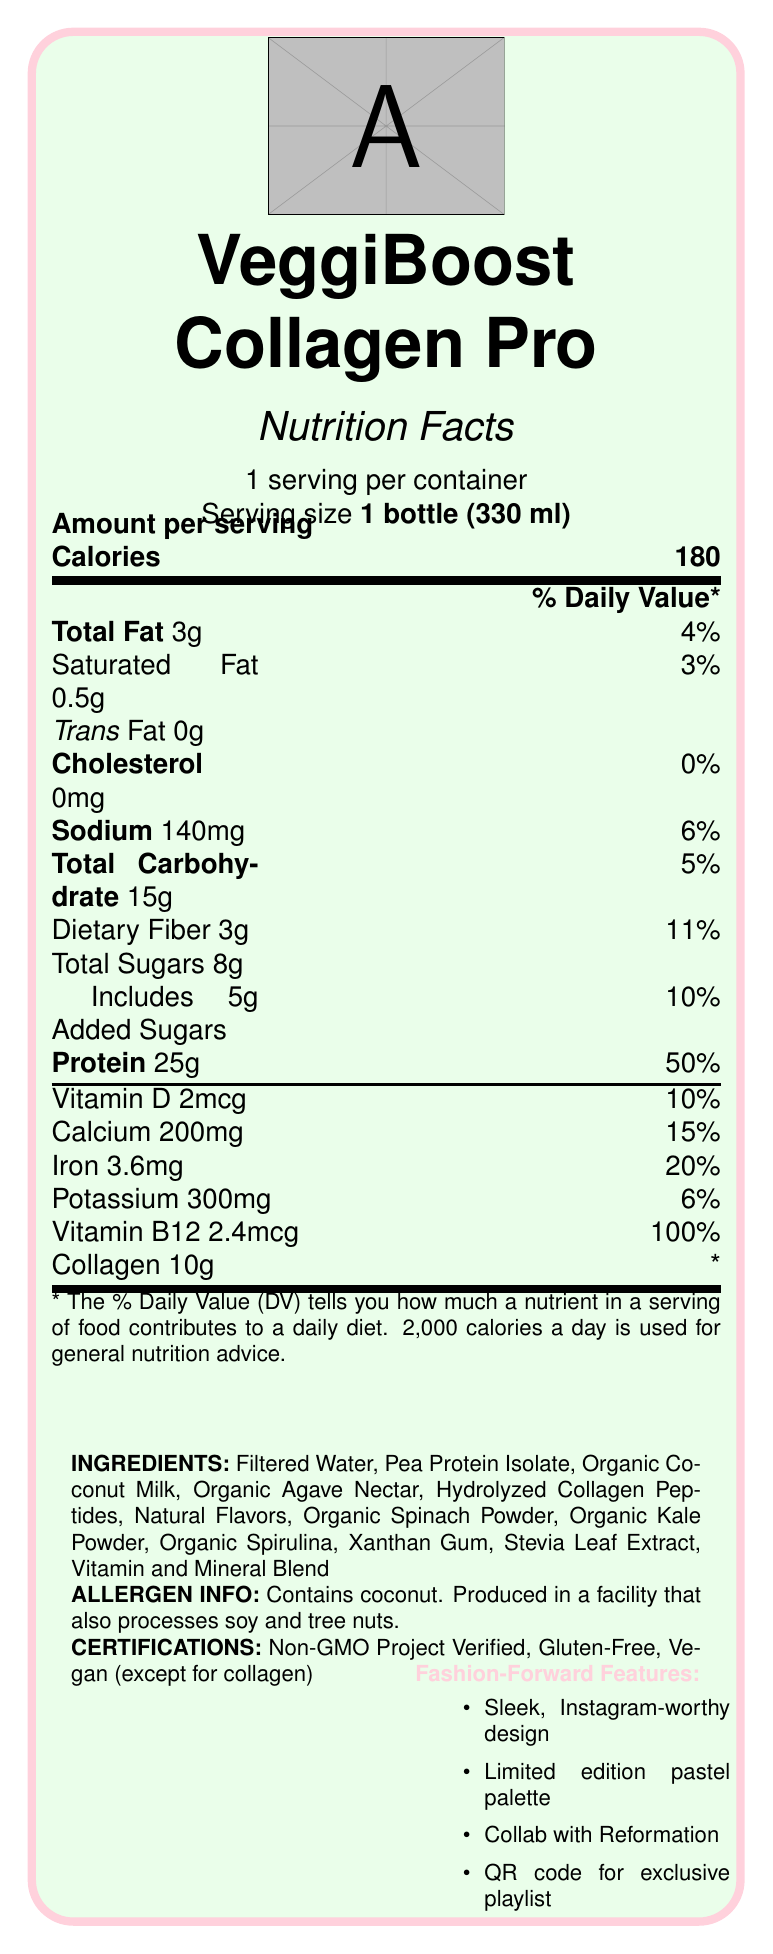What is the serving size of VeggiBoost Collagen Pro? The document specifies the serving size directly in the Nutrition Facts section.
Answer: 1 bottle (330 ml) How many calories are in one serving of VeggiBoost Collagen Pro? The document lists the calories per serving directly under the calories heading.
Answer: 180 What percentage of the daily value of protein does one serving provide? The document states that one serving contains 25g of protein, which is 50% of the daily value.
Answer: 50% How much collagen is in one serving of VeggiBoost Collagen Pro? The document lists collagen as 10g per serving.
Answer: 10g What allergens does the product contain or get processed with? This information is found in the allergen info section.
Answer: Contains coconut. Produced in a facility that also processes soy and tree nuts. Which store offers the lowest price for VeggiBoost Collagen Pro? 
A. Target 
B. Costco 
C. TJ Maxx The document lists Costco as offering the product at $2.99 when purchased in bulk, which is the lowest price listed.
Answer: B How much added sugar does this product contain per serving?
A. 3g 
B. 5g 
C. 8g 
D. 10g The document states that the product includes 5g of added sugars.
Answer: B Is VeggiBoost Collagen Pro vegan? Although it is generally plant-based, the inclusion of collagen, which is not vegan, makes the product non-vegan.
Answer: No Describe the key features of VeggiBoost Collagen Pro as shown in the document. The explanation draws from various sections of the document, including nutritional information, marketing claims, and design features.
Answer: VeggiBoost Collagen Pro is a trendy plant-based protein shake that also contains collagen. It has 180 calories per serving, 25g of protein, 10g of collagen, and various vitamins and minerals. It is available in a sleek bottle with a limited edition pastel color palette and collaborations with fashion brand Reformation. It includes a QR code linking to an exclusive workout playlist. What is the primary source of protein in VeggiBoost Collagen Pro? The ingredients list "Pea Protein Isolate" as the key ingredient for protein.
Answer: Pea Protein Isolate What is the percentage of the daily value for fiber provided by one serving? The daily value percentage for dietary fiber per serving is listed as 11% in the document.
Answer: 11% Which certification is NOT mentioned for VeggiBoost Collagen Pro?
A. Non-GMO Project Verified 
B. Organic 
C. Gluten-Free 
D. Vegan (except for collagen) The document lists Non-GMO Project Verified, Gluten-Free, and Vegan (except for collagen) but does not mention an organic certification.
Answer: B What are the marketing claims associated with this product? These claims are listed under the marketing claims section in the document.
Answer: 25g plant-based protein per serving, 10g collagen for skin and joint health, no artificial flavors or preservatives, supports muscle recovery and growth, promotes radiant skin and healthy hair Does this product contain artificial flavors? The marketing claims section explicitly states that the product has no artificial flavors or preservatives.
Answer: No What is the daily value percentage for Vitamin B12 in one serving? The document lists that one serving of the product provides 100% of the daily value for Vitamin B12.
Answer: 100% What is the retail price of VeggiBoost Collagen Pro? The retail price is listed in the document.
Answer: $4.99 What kind of playlist can be accessed via the QR code on the bottle? This information is provided in the fashion-forward features section.
Answer: An exclusive workout playlist curated by top fitness influencers Who collaborated on the design of VeggiBoost Collagen Pro's bottle? The fashion-forward features section lists Reformation as the collaborating eco-conscious fashion brand.
Answer: Reformation Which nutrient has the highest daily value percentage in one serving?
A. Protein 
B. Vitamin D 
C. Iron 
D. Vitamin B12 Vitamin B12 has the highest daily value percentage at 100%, compared to protein (50%), Vitamin D (10%), and iron (20%).
Answer: D Is it possible to determine the overall taste profile of VeggiBoost Collagen Pro from the document? The document does not provide specific information on the taste profile of the product.
Answer: Cannot be determined 